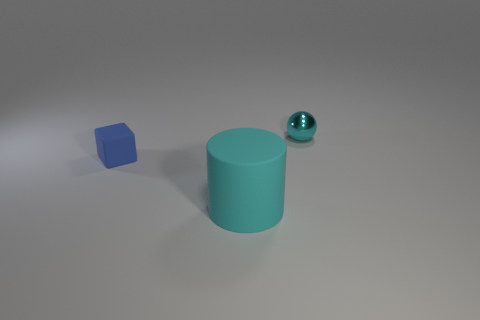Add 3 blue rubber things. How many objects exist? 6 Subtract all cylinders. How many objects are left? 2 Add 3 matte cylinders. How many matte cylinders exist? 4 Subtract 0 blue cylinders. How many objects are left? 3 Subtract all large blue shiny objects. Subtract all cyan balls. How many objects are left? 2 Add 2 big objects. How many big objects are left? 3 